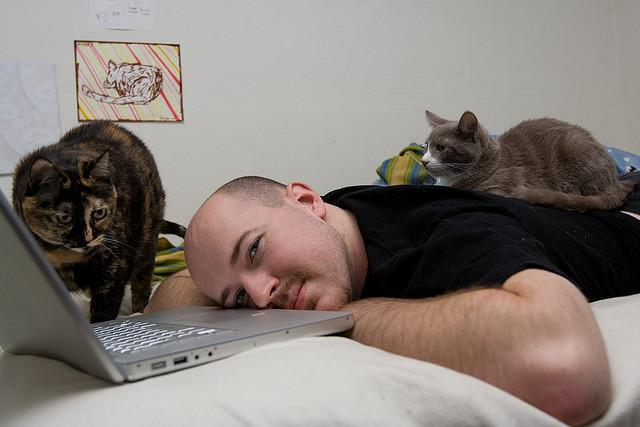How many mammals area shown?

Choices:
A) one
B) ten
C) three
D) two three 